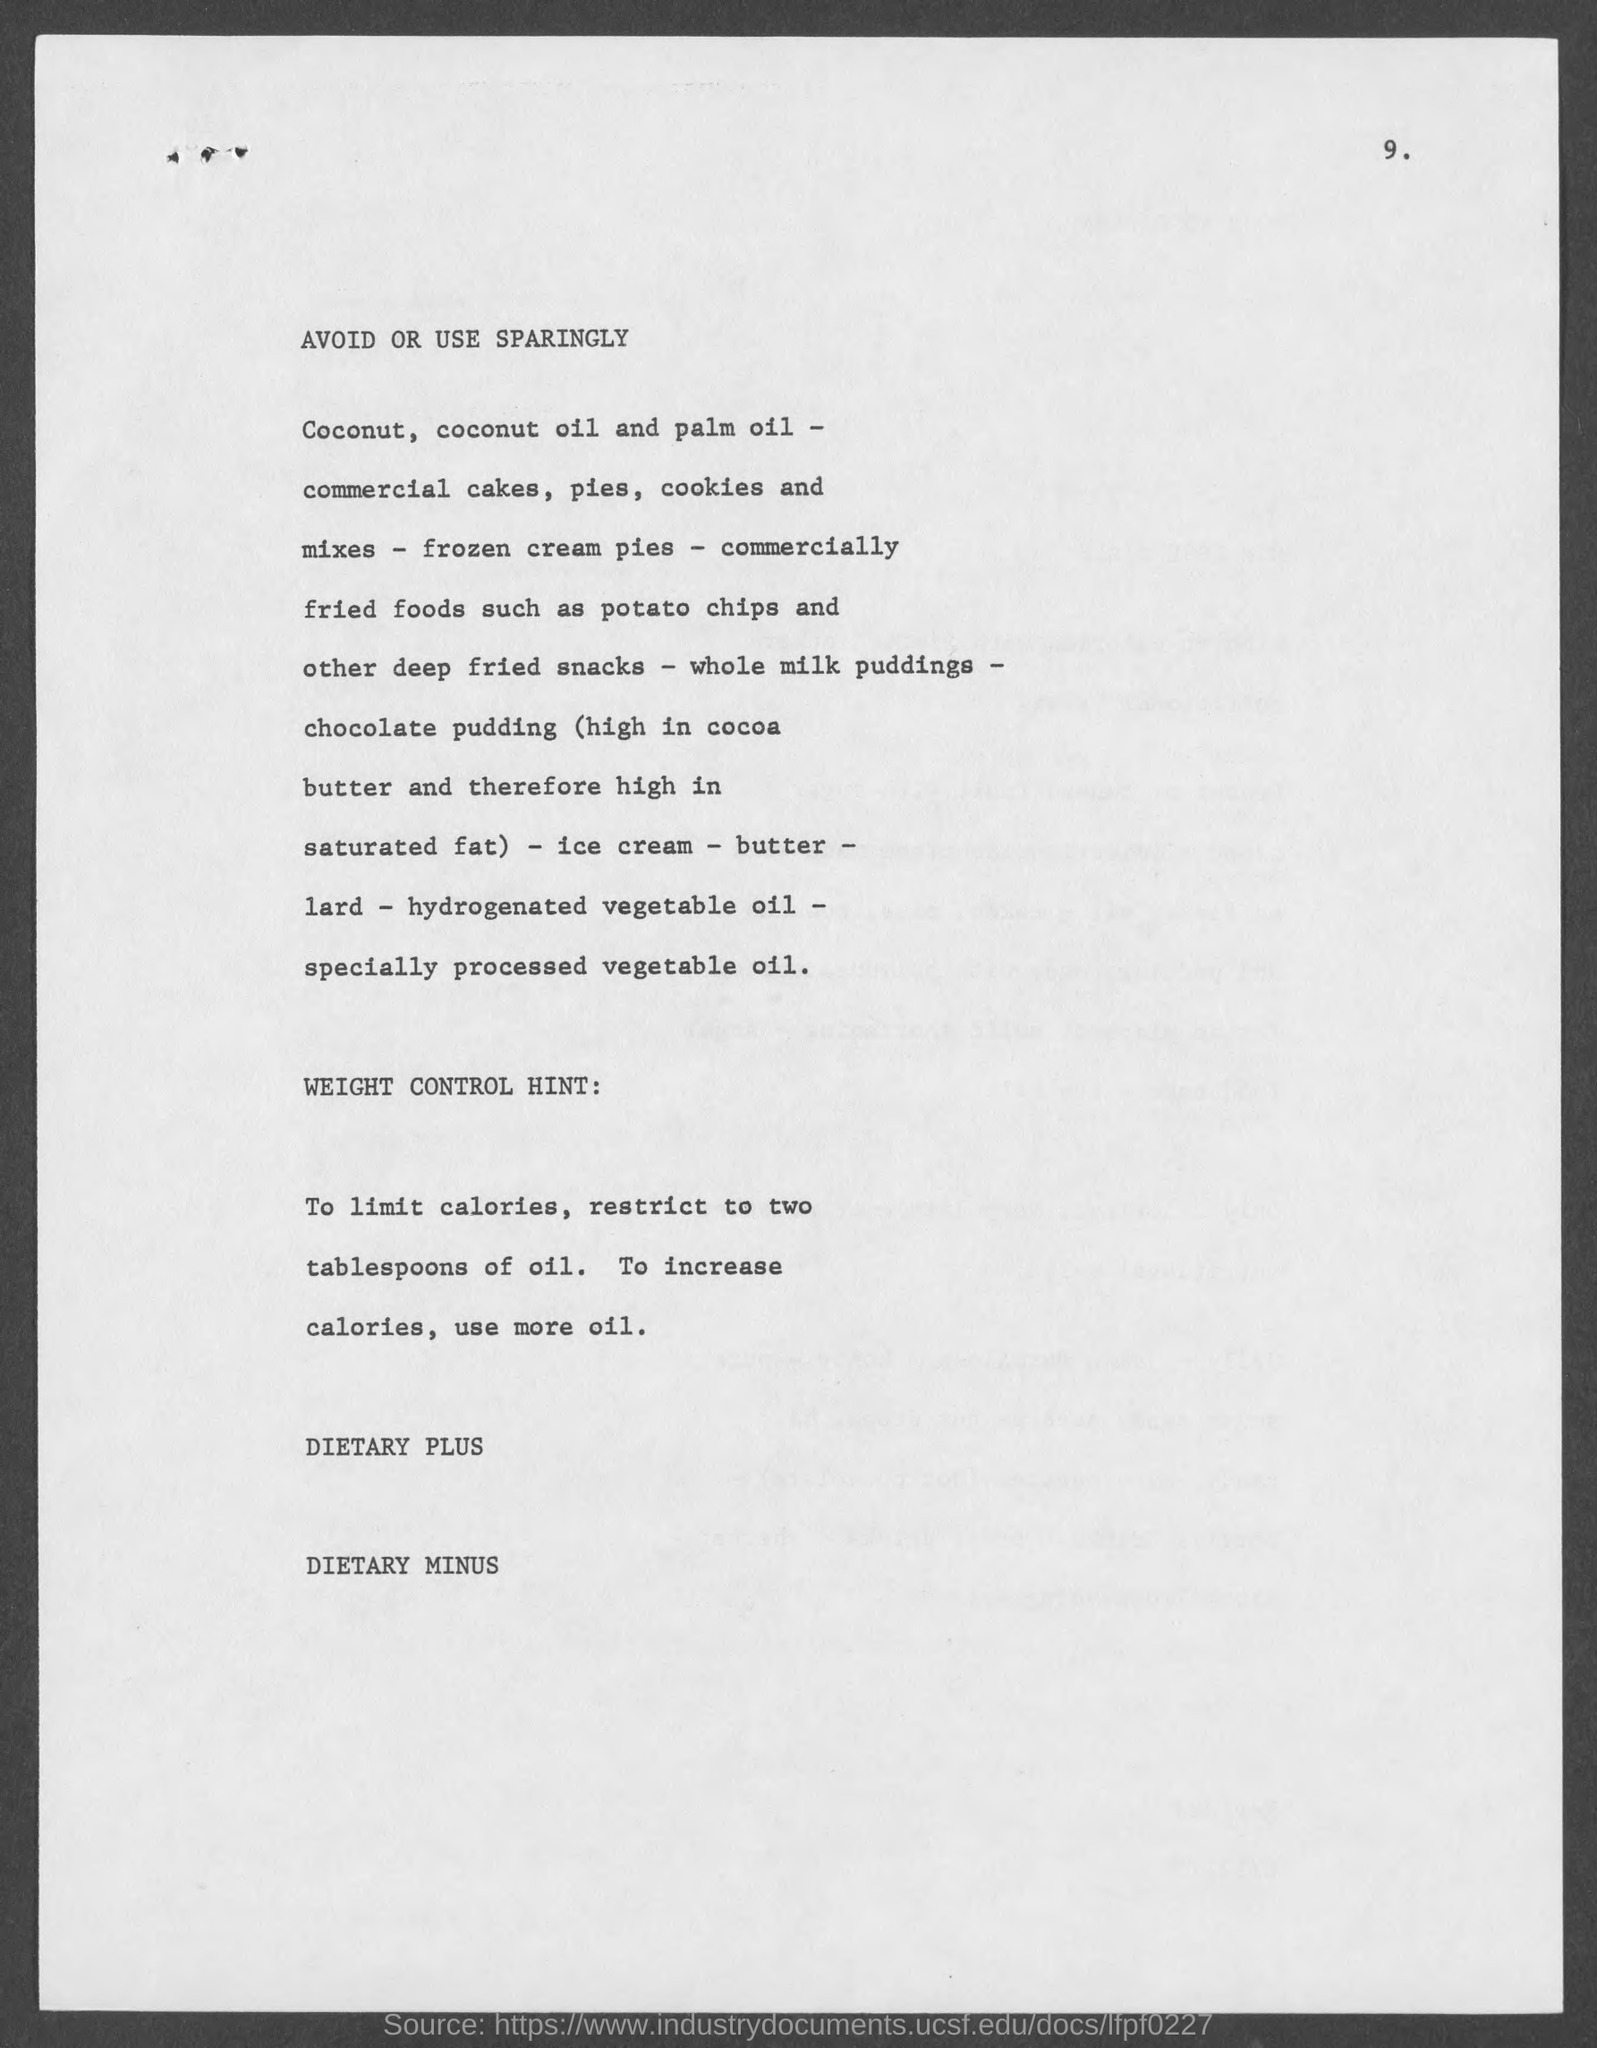Indicate a few pertinent items in this graphic. The third title in the document is 'Dietary plus...' The second title in the document is 'Weight Control Hint...' The first title in the document is to be avoided or used sparingly. The fourth title in the document is 'DIETARY MINUS....' The page number is 9. 